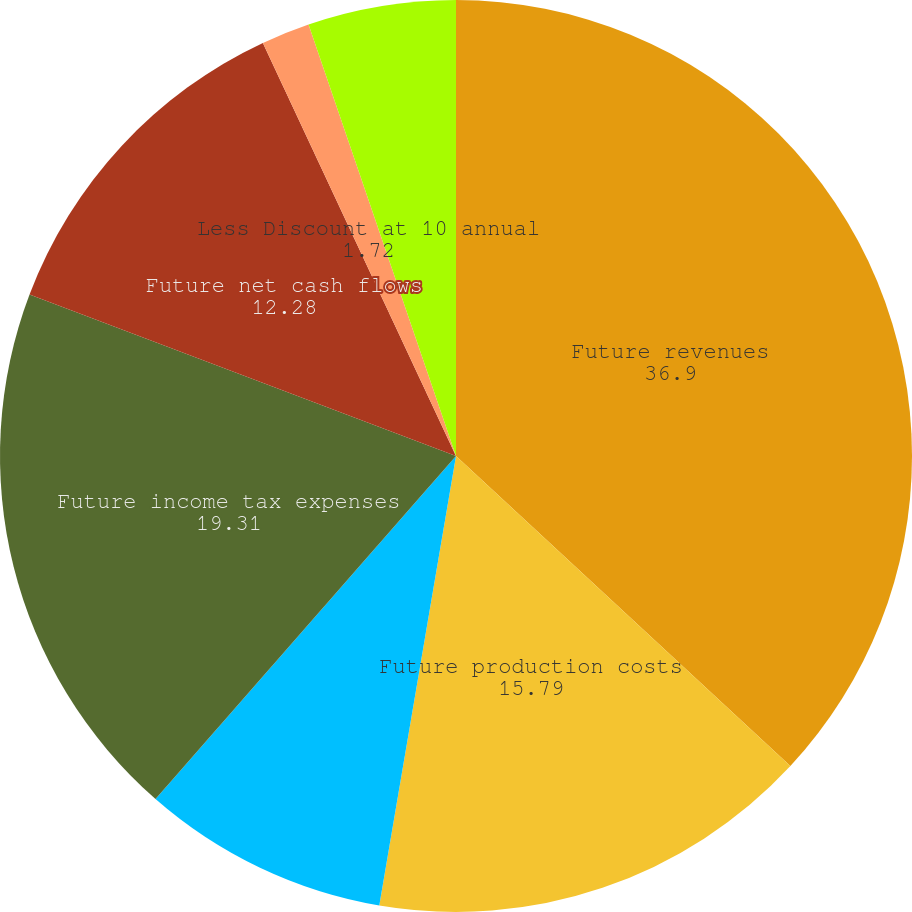Convert chart. <chart><loc_0><loc_0><loc_500><loc_500><pie_chart><fcel>Future revenues<fcel>Future production costs<fcel>Future development costs<fcel>Future income tax expenses<fcel>Future net cash flows<fcel>Less Discount at 10 annual<fcel>Standardized measure of<nl><fcel>36.9%<fcel>15.79%<fcel>8.76%<fcel>19.31%<fcel>12.28%<fcel>1.72%<fcel>5.24%<nl></chart> 